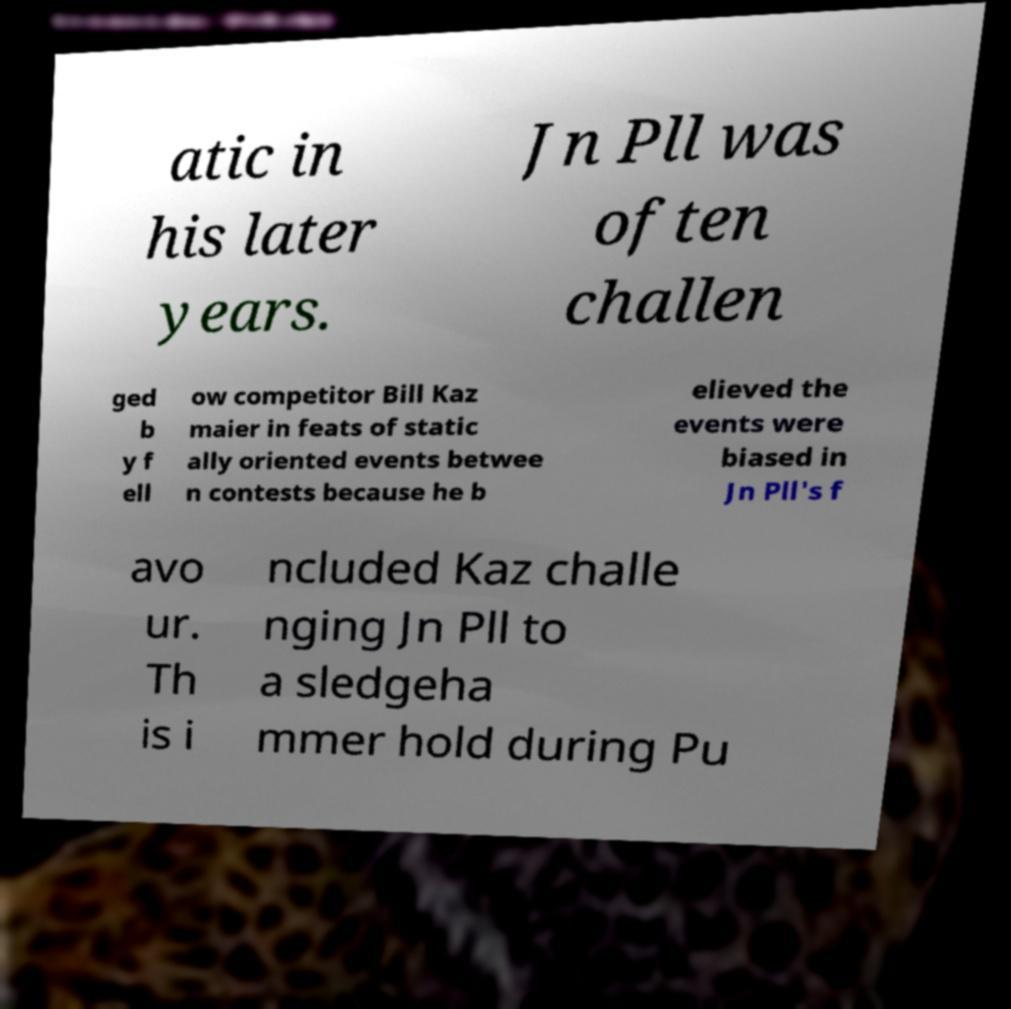Please identify and transcribe the text found in this image. atic in his later years. Jn Pll was often challen ged b y f ell ow competitor Bill Kaz maier in feats of static ally oriented events betwee n contests because he b elieved the events were biased in Jn Pll's f avo ur. Th is i ncluded Kaz challe nging Jn Pll to a sledgeha mmer hold during Pu 